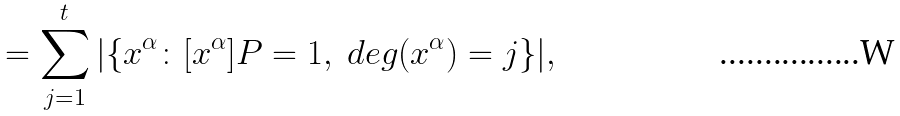Convert formula to latex. <formula><loc_0><loc_0><loc_500><loc_500>= \sum _ { j = 1 } ^ { t } | \{ x ^ { \alpha } \colon [ x ^ { \alpha } ] P = 1 , \ d e g ( x ^ { \alpha } ) = j \} | ,</formula> 